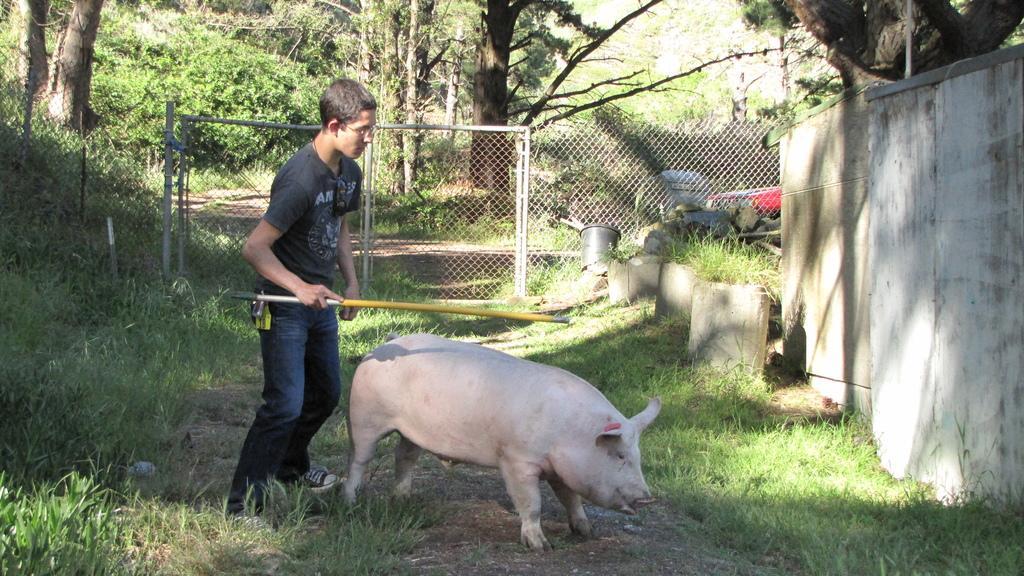Can you describe this image briefly? In the background we can see trees and fence. In this picture we can see poles, objects, plants and grass. We can see a man wearing spectacles and he is holding an object. We can see a pig. On the right side of the picture we can see the wall. 